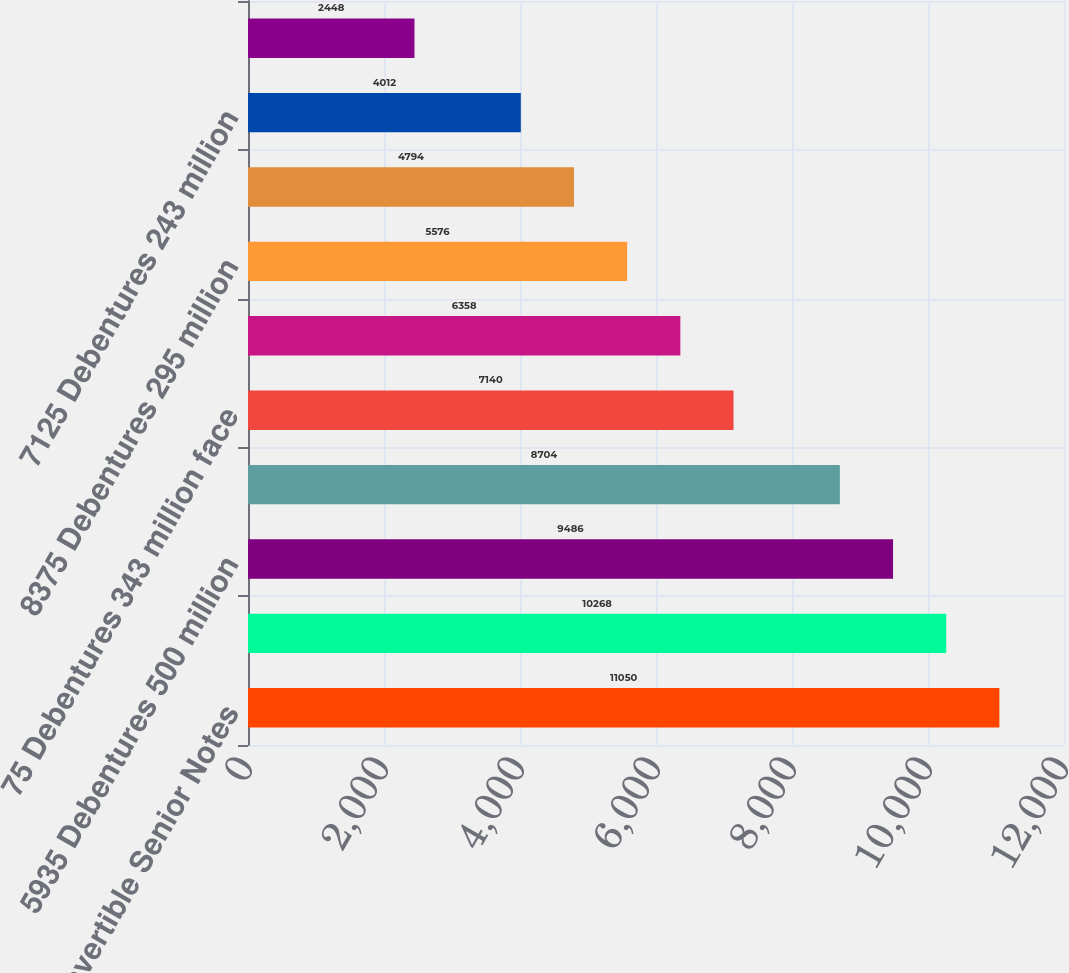<chart> <loc_0><loc_0><loc_500><loc_500><bar_chart><fcel>0875 Convertible Senior Notes<fcel>5375 Debentures 600 million<fcel>5935 Debentures 500 million<fcel>70 Debentures 400 million face<fcel>75 Debentures 343 million face<fcel>6625 Debentures 298 million<fcel>8375 Debentures 295 million<fcel>695 Debentures 250 million<fcel>7125 Debentures 243 million<fcel>675 Debentures 200 million<nl><fcel>11050<fcel>10268<fcel>9486<fcel>8704<fcel>7140<fcel>6358<fcel>5576<fcel>4794<fcel>4012<fcel>2448<nl></chart> 